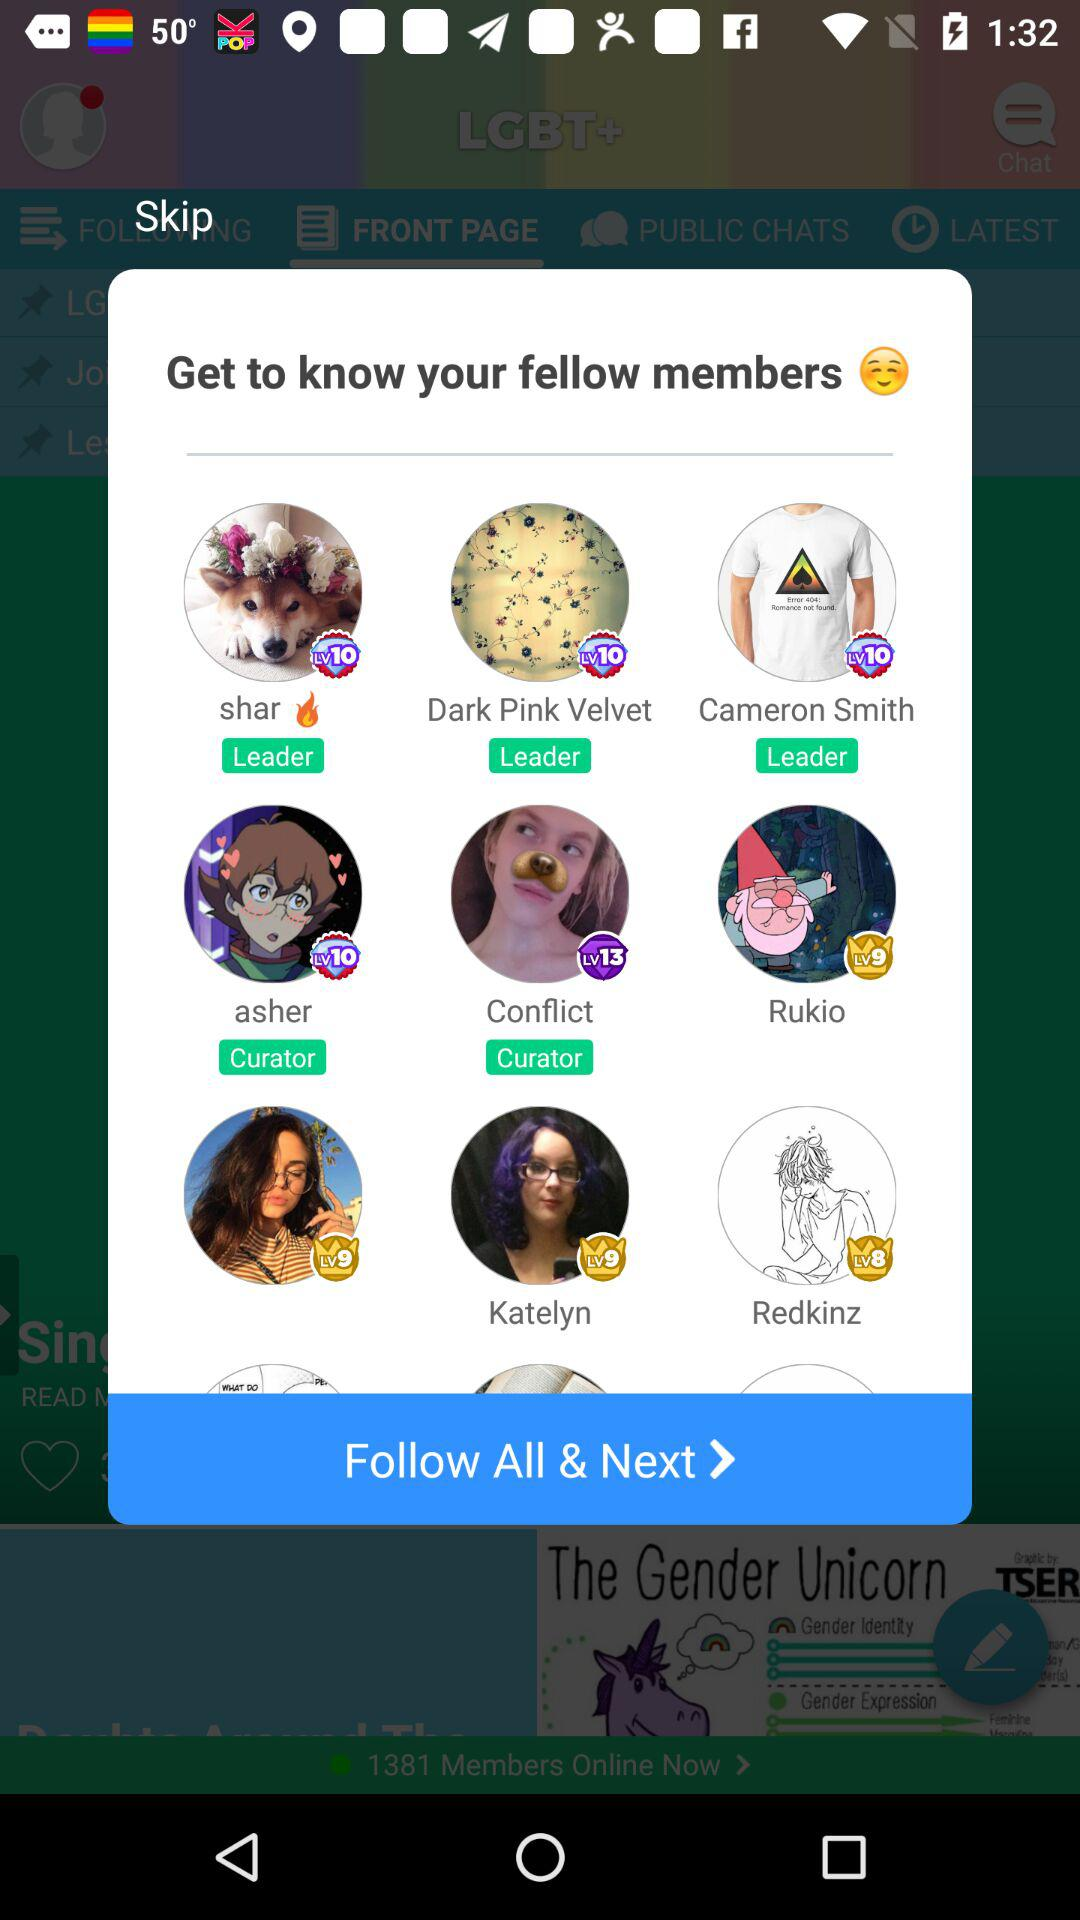How many leaders are there?
Answer the question using a single word or phrase. 3 